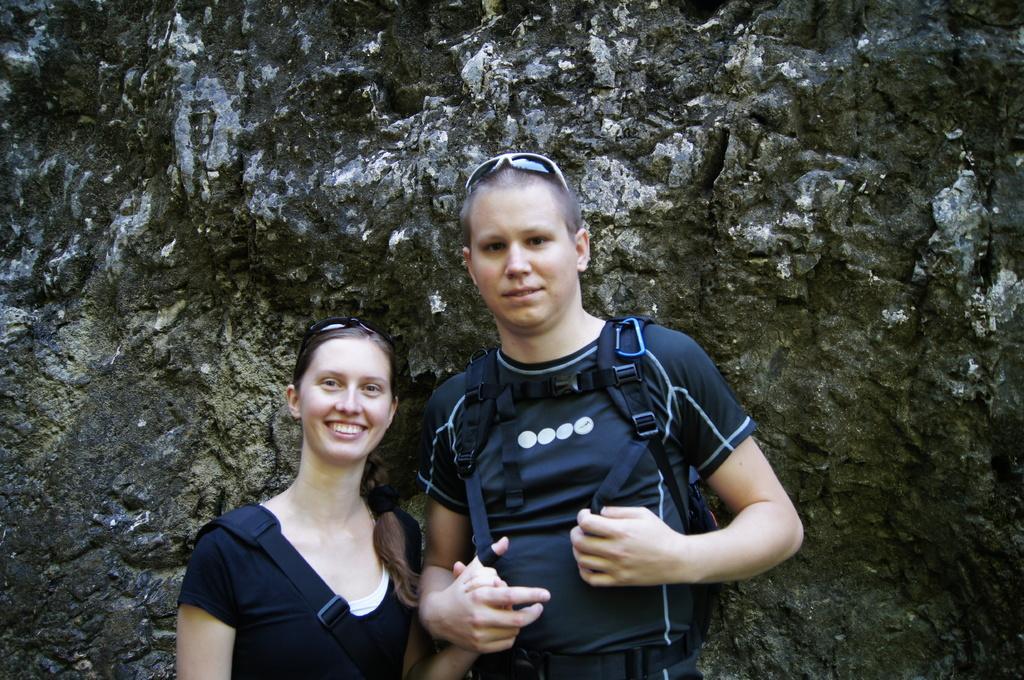Could you give a brief overview of what you see in this image? In this picture we can see two persons standing and smiling here, a person on the right side is carrying a backpack. 